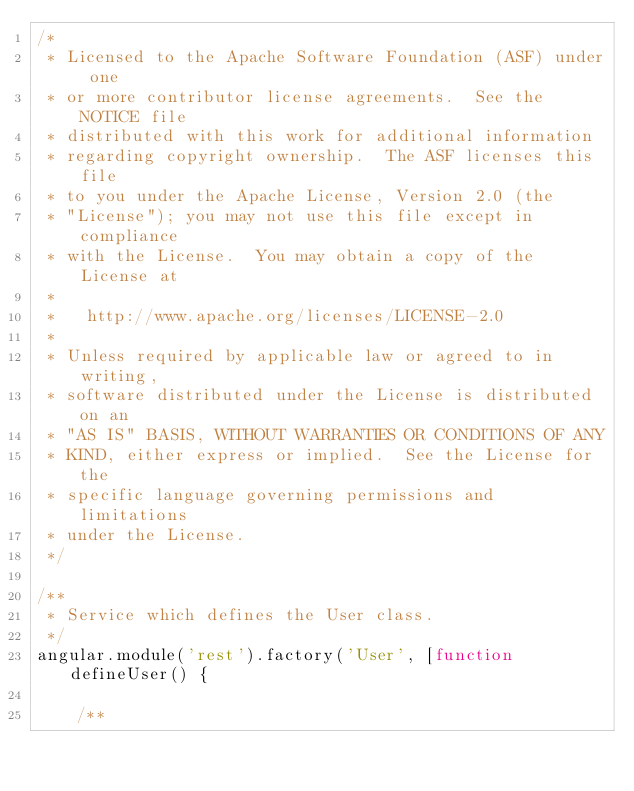<code> <loc_0><loc_0><loc_500><loc_500><_JavaScript_>/*
 * Licensed to the Apache Software Foundation (ASF) under one
 * or more contributor license agreements.  See the NOTICE file
 * distributed with this work for additional information
 * regarding copyright ownership.  The ASF licenses this file
 * to you under the Apache License, Version 2.0 (the
 * "License"); you may not use this file except in compliance
 * with the License.  You may obtain a copy of the License at
 *
 *   http://www.apache.org/licenses/LICENSE-2.0
 *
 * Unless required by applicable law or agreed to in writing,
 * software distributed under the License is distributed on an
 * "AS IS" BASIS, WITHOUT WARRANTIES OR CONDITIONS OF ANY
 * KIND, either express or implied.  See the License for the
 * specific language governing permissions and limitations
 * under the License.
 */

/**
 * Service which defines the User class.
 */
angular.module('rest').factory('User', [function defineUser() {
            
    /**</code> 